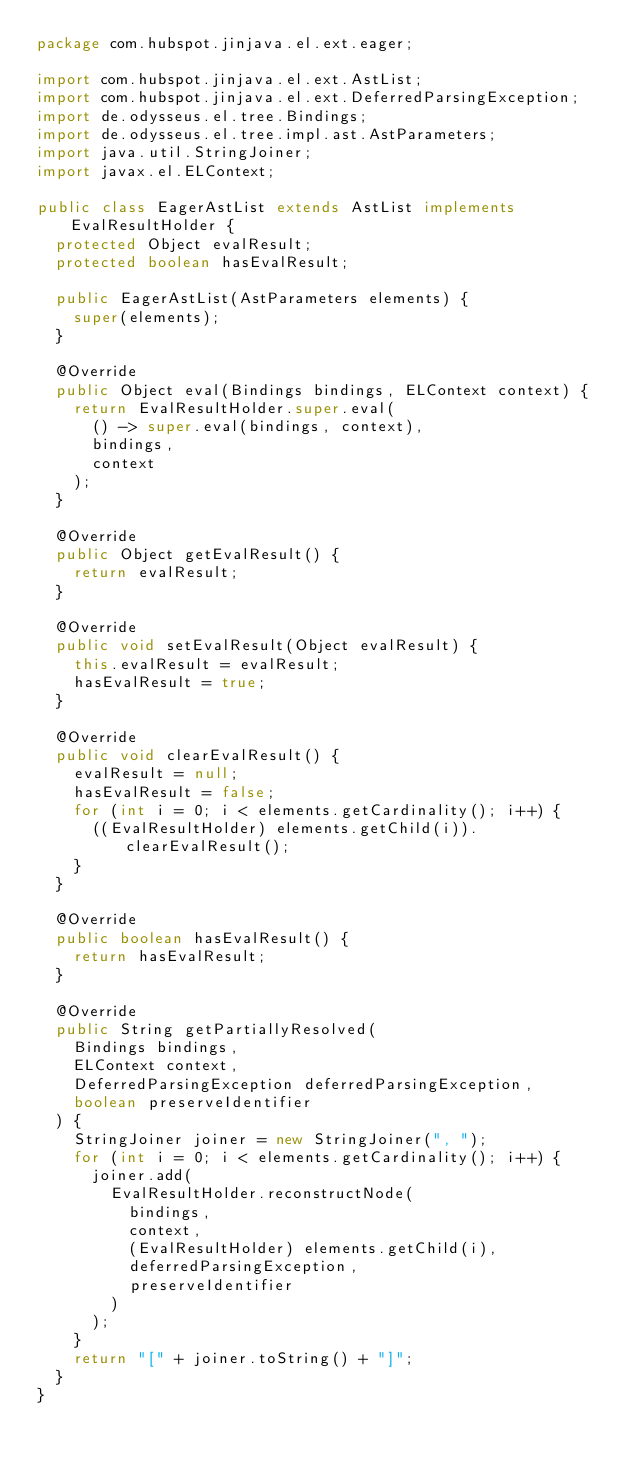<code> <loc_0><loc_0><loc_500><loc_500><_Java_>package com.hubspot.jinjava.el.ext.eager;

import com.hubspot.jinjava.el.ext.AstList;
import com.hubspot.jinjava.el.ext.DeferredParsingException;
import de.odysseus.el.tree.Bindings;
import de.odysseus.el.tree.impl.ast.AstParameters;
import java.util.StringJoiner;
import javax.el.ELContext;

public class EagerAstList extends AstList implements EvalResultHolder {
  protected Object evalResult;
  protected boolean hasEvalResult;

  public EagerAstList(AstParameters elements) {
    super(elements);
  }

  @Override
  public Object eval(Bindings bindings, ELContext context) {
    return EvalResultHolder.super.eval(
      () -> super.eval(bindings, context),
      bindings,
      context
    );
  }

  @Override
  public Object getEvalResult() {
    return evalResult;
  }

  @Override
  public void setEvalResult(Object evalResult) {
    this.evalResult = evalResult;
    hasEvalResult = true;
  }

  @Override
  public void clearEvalResult() {
    evalResult = null;
    hasEvalResult = false;
    for (int i = 0; i < elements.getCardinality(); i++) {
      ((EvalResultHolder) elements.getChild(i)).clearEvalResult();
    }
  }

  @Override
  public boolean hasEvalResult() {
    return hasEvalResult;
  }

  @Override
  public String getPartiallyResolved(
    Bindings bindings,
    ELContext context,
    DeferredParsingException deferredParsingException,
    boolean preserveIdentifier
  ) {
    StringJoiner joiner = new StringJoiner(", ");
    for (int i = 0; i < elements.getCardinality(); i++) {
      joiner.add(
        EvalResultHolder.reconstructNode(
          bindings,
          context,
          (EvalResultHolder) elements.getChild(i),
          deferredParsingException,
          preserveIdentifier
        )
      );
    }
    return "[" + joiner.toString() + "]";
  }
}
</code> 